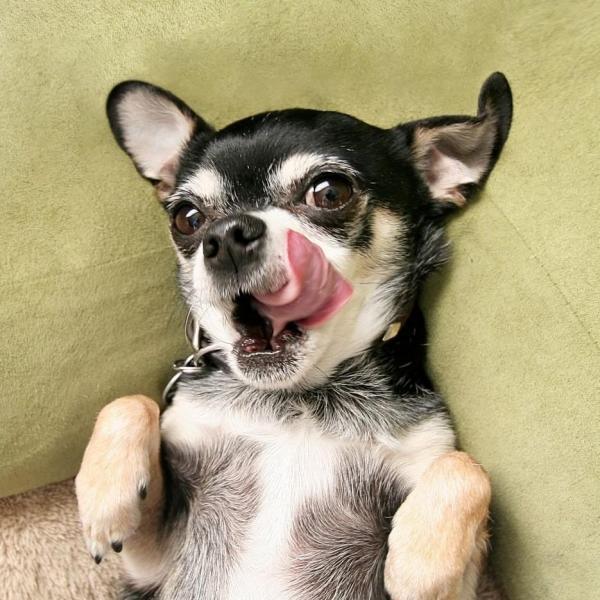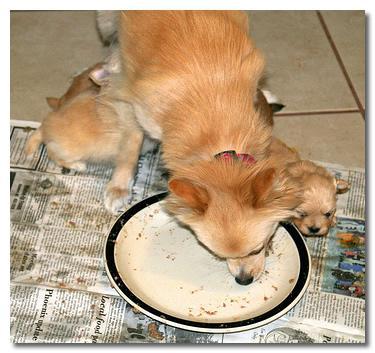The first image is the image on the left, the second image is the image on the right. For the images shown, is this caption "Two dogs are shown standing near food." true? Answer yes or no. No. The first image is the image on the left, the second image is the image on the right. Analyze the images presented: Is the assertion "At least one image shows a single dog standing behind a white plate with multiple food items on it." valid? Answer yes or no. No. 